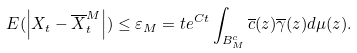<formula> <loc_0><loc_0><loc_500><loc_500>E ( \left | X _ { t } - \overline { X } _ { t } ^ { M } \right | ) \leq \varepsilon _ { M } = t e ^ { C t } \int _ { B _ { M } ^ { c } } \overline { c } ( z ) \overline { \gamma } ( z ) d \mu ( z ) .</formula> 